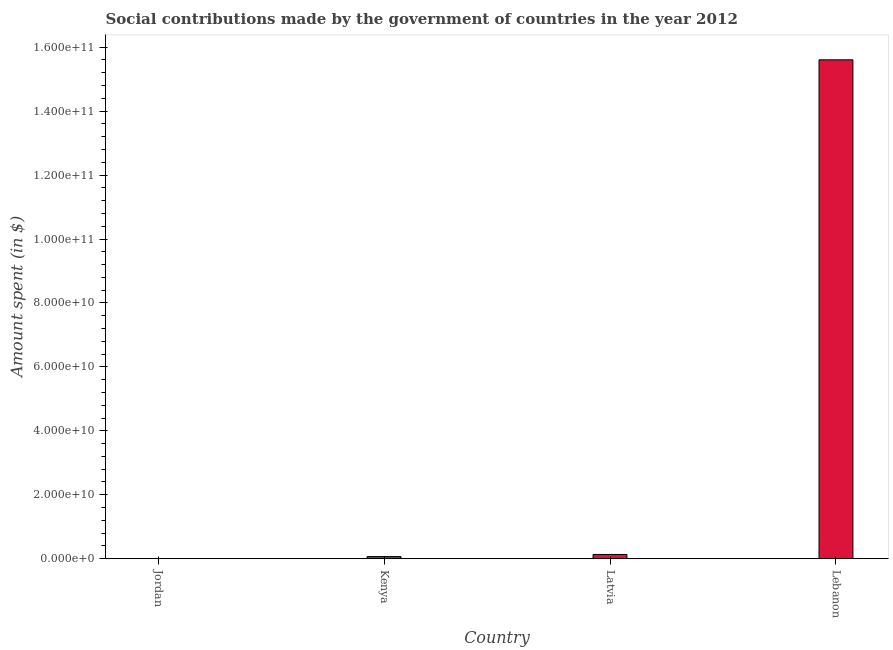Does the graph contain any zero values?
Your response must be concise. No. What is the title of the graph?
Keep it short and to the point. Social contributions made by the government of countries in the year 2012. What is the label or title of the X-axis?
Offer a very short reply. Country. What is the label or title of the Y-axis?
Provide a succinct answer. Amount spent (in $). What is the amount spent in making social contributions in Latvia?
Your response must be concise. 1.32e+09. Across all countries, what is the maximum amount spent in making social contributions?
Your answer should be compact. 1.56e+11. Across all countries, what is the minimum amount spent in making social contributions?
Offer a very short reply. 2.43e+07. In which country was the amount spent in making social contributions maximum?
Give a very brief answer. Lebanon. In which country was the amount spent in making social contributions minimum?
Your answer should be compact. Jordan. What is the sum of the amount spent in making social contributions?
Your response must be concise. 1.58e+11. What is the difference between the amount spent in making social contributions in Kenya and Latvia?
Your response must be concise. -6.64e+08. What is the average amount spent in making social contributions per country?
Keep it short and to the point. 3.95e+1. What is the median amount spent in making social contributions?
Make the answer very short. 9.92e+08. What is the ratio of the amount spent in making social contributions in Kenya to that in Latvia?
Give a very brief answer. 0.5. Is the amount spent in making social contributions in Latvia less than that in Lebanon?
Make the answer very short. Yes. What is the difference between the highest and the second highest amount spent in making social contributions?
Your answer should be very brief. 1.55e+11. Is the sum of the amount spent in making social contributions in Jordan and Latvia greater than the maximum amount spent in making social contributions across all countries?
Offer a terse response. No. What is the difference between the highest and the lowest amount spent in making social contributions?
Offer a terse response. 1.56e+11. In how many countries, is the amount spent in making social contributions greater than the average amount spent in making social contributions taken over all countries?
Ensure brevity in your answer.  1. Are all the bars in the graph horizontal?
Your response must be concise. No. What is the difference between two consecutive major ticks on the Y-axis?
Offer a terse response. 2.00e+1. What is the Amount spent (in $) in Jordan?
Your answer should be very brief. 2.43e+07. What is the Amount spent (in $) of Kenya?
Your answer should be very brief. 6.60e+08. What is the Amount spent (in $) of Latvia?
Provide a succinct answer. 1.32e+09. What is the Amount spent (in $) of Lebanon?
Offer a terse response. 1.56e+11. What is the difference between the Amount spent (in $) in Jordan and Kenya?
Your answer should be very brief. -6.35e+08. What is the difference between the Amount spent (in $) in Jordan and Latvia?
Your answer should be compact. -1.30e+09. What is the difference between the Amount spent (in $) in Jordan and Lebanon?
Give a very brief answer. -1.56e+11. What is the difference between the Amount spent (in $) in Kenya and Latvia?
Your answer should be very brief. -6.64e+08. What is the difference between the Amount spent (in $) in Kenya and Lebanon?
Your response must be concise. -1.55e+11. What is the difference between the Amount spent (in $) in Latvia and Lebanon?
Ensure brevity in your answer.  -1.55e+11. What is the ratio of the Amount spent (in $) in Jordan to that in Kenya?
Your answer should be very brief. 0.04. What is the ratio of the Amount spent (in $) in Jordan to that in Latvia?
Keep it short and to the point. 0.02. What is the ratio of the Amount spent (in $) in Jordan to that in Lebanon?
Your response must be concise. 0. What is the ratio of the Amount spent (in $) in Kenya to that in Latvia?
Ensure brevity in your answer.  0.5. What is the ratio of the Amount spent (in $) in Kenya to that in Lebanon?
Your answer should be compact. 0. What is the ratio of the Amount spent (in $) in Latvia to that in Lebanon?
Provide a short and direct response. 0.01. 